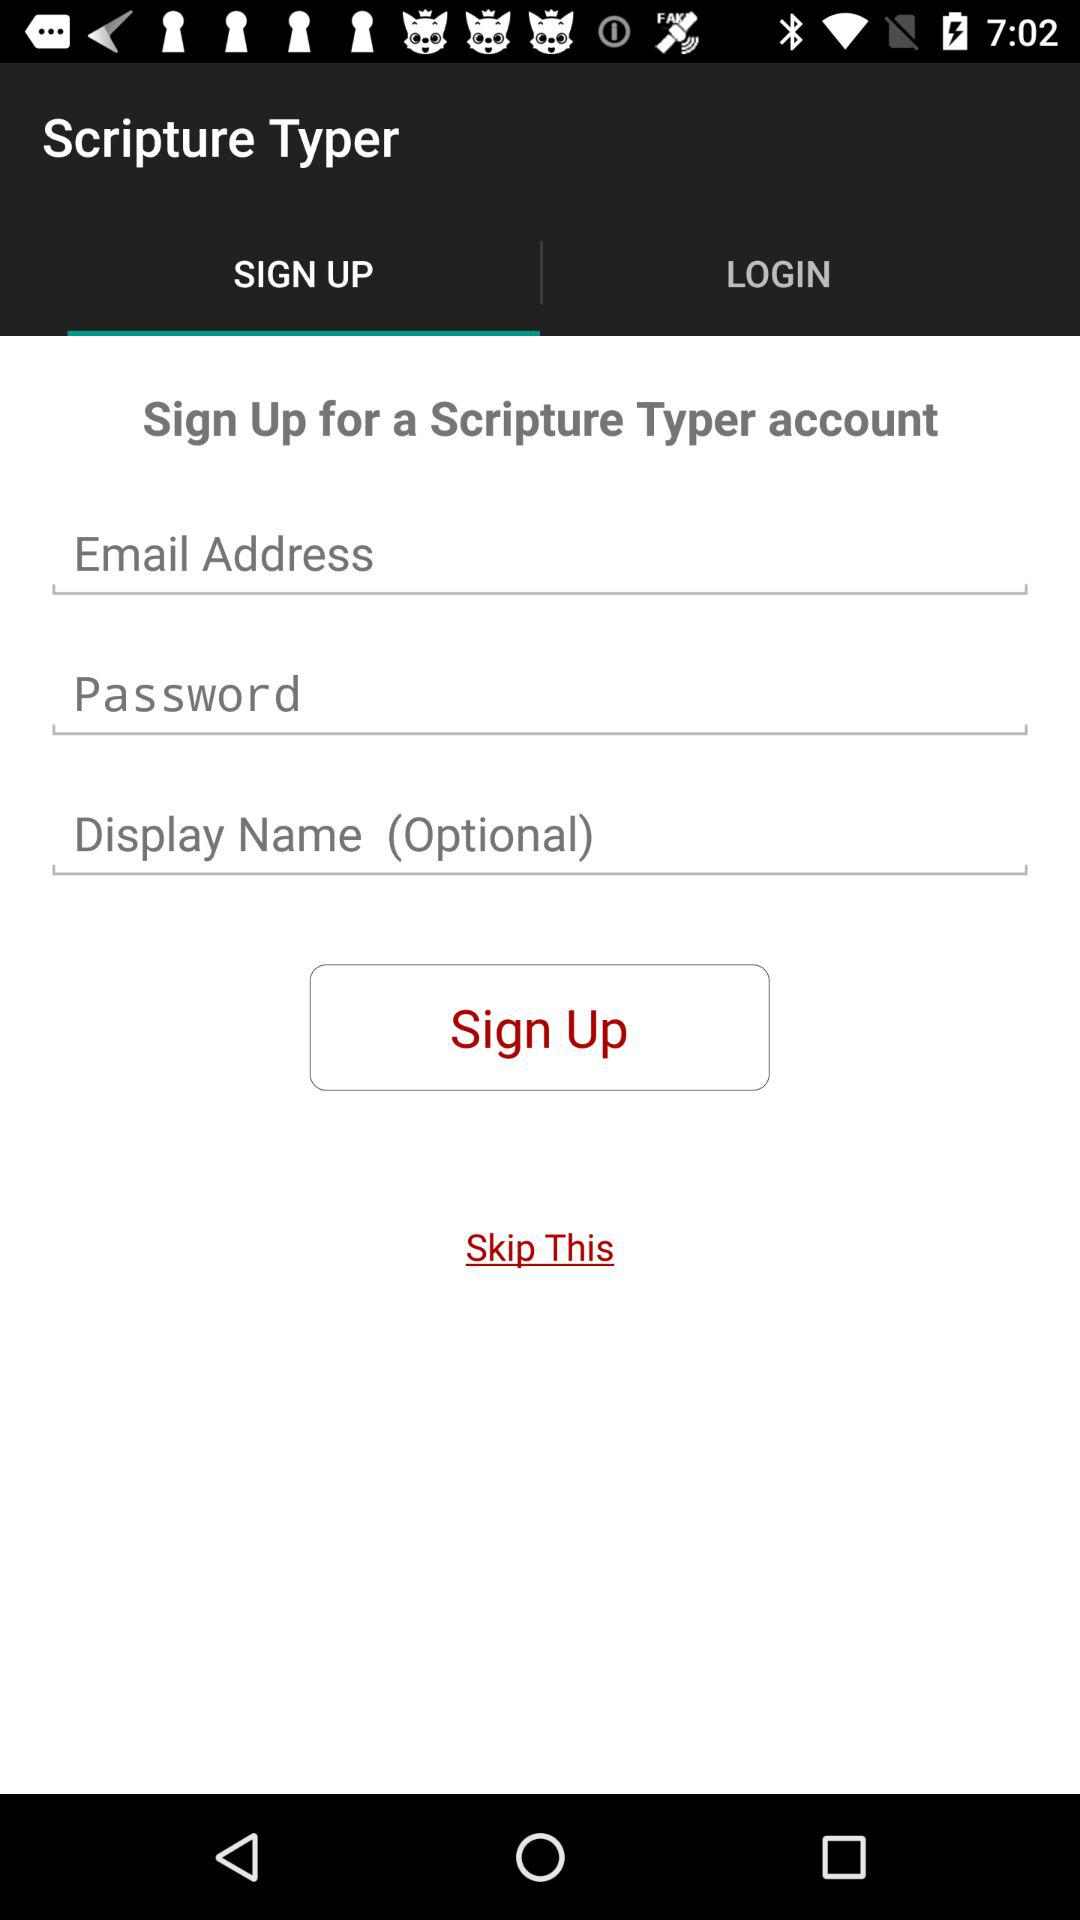Which tab has been selected? The selected tab is "SIGN UP". 